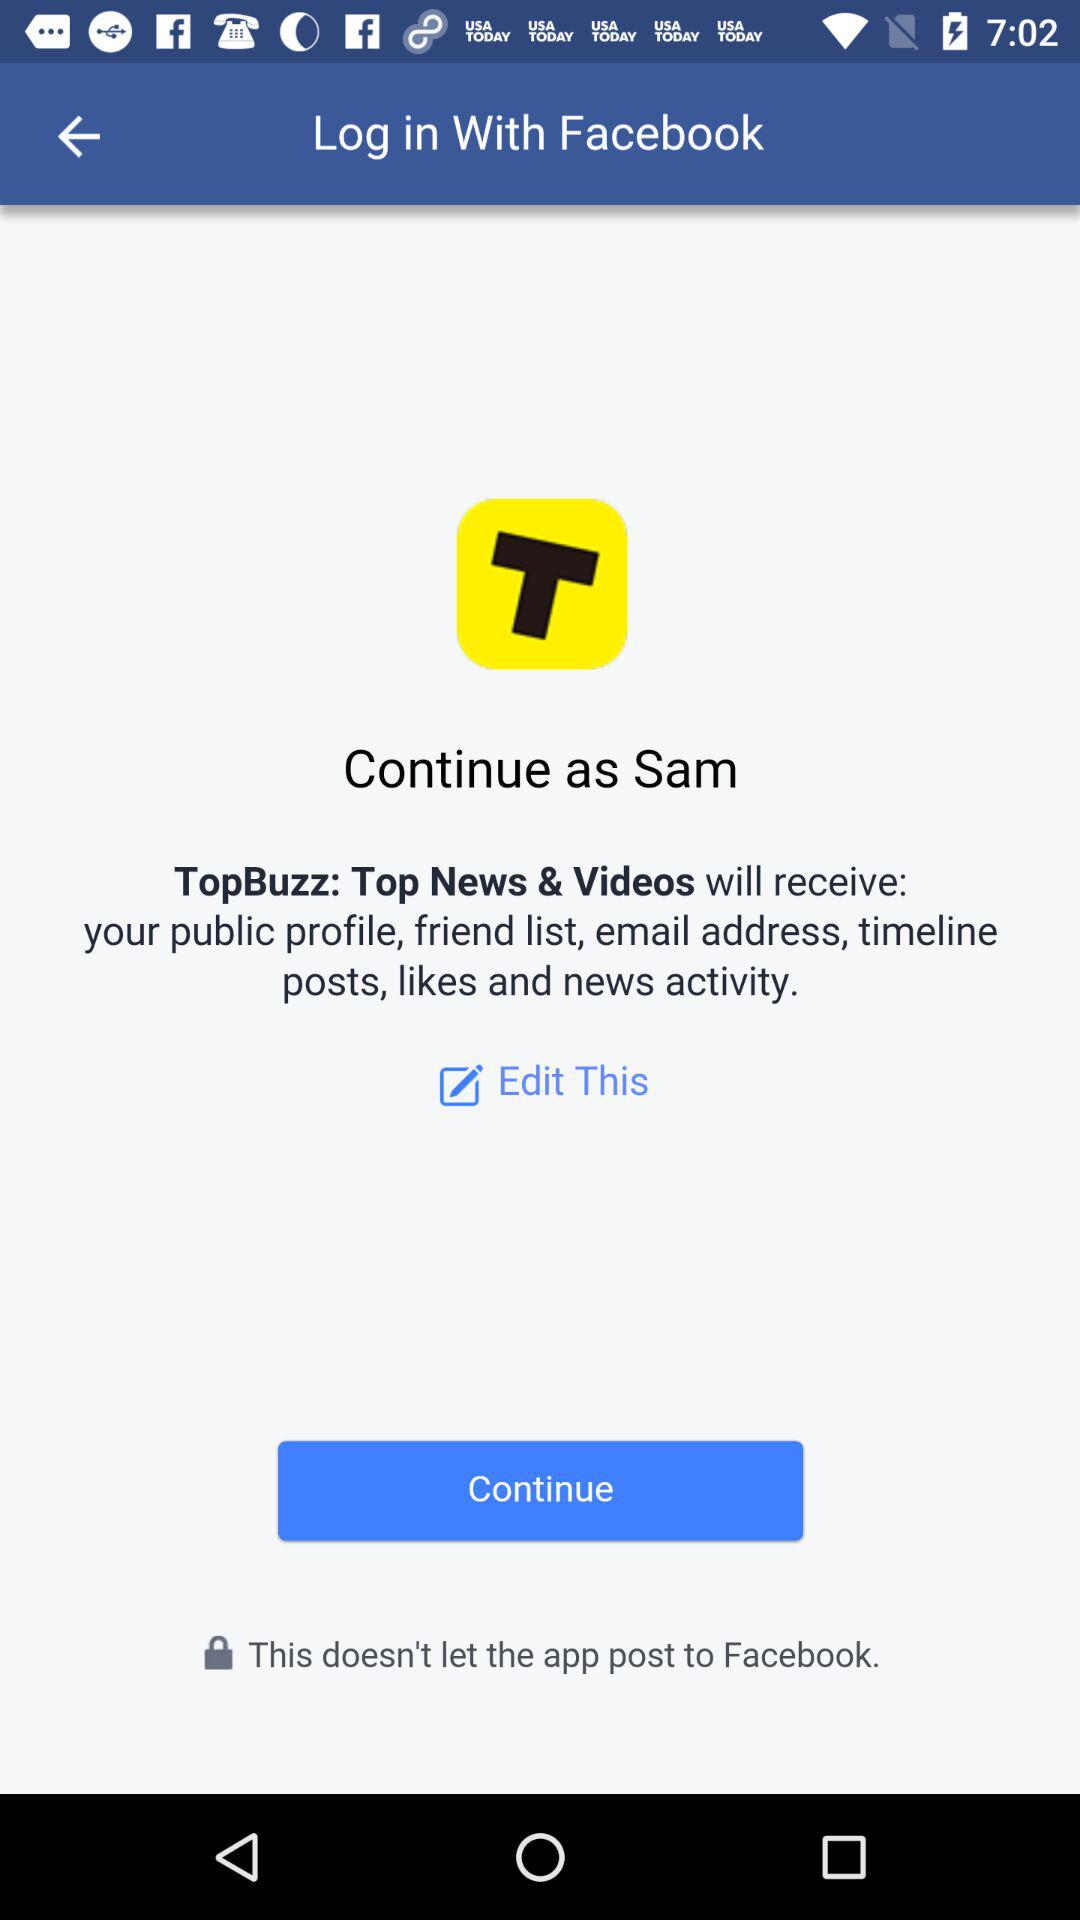What is the user name? The user name is Sam. 